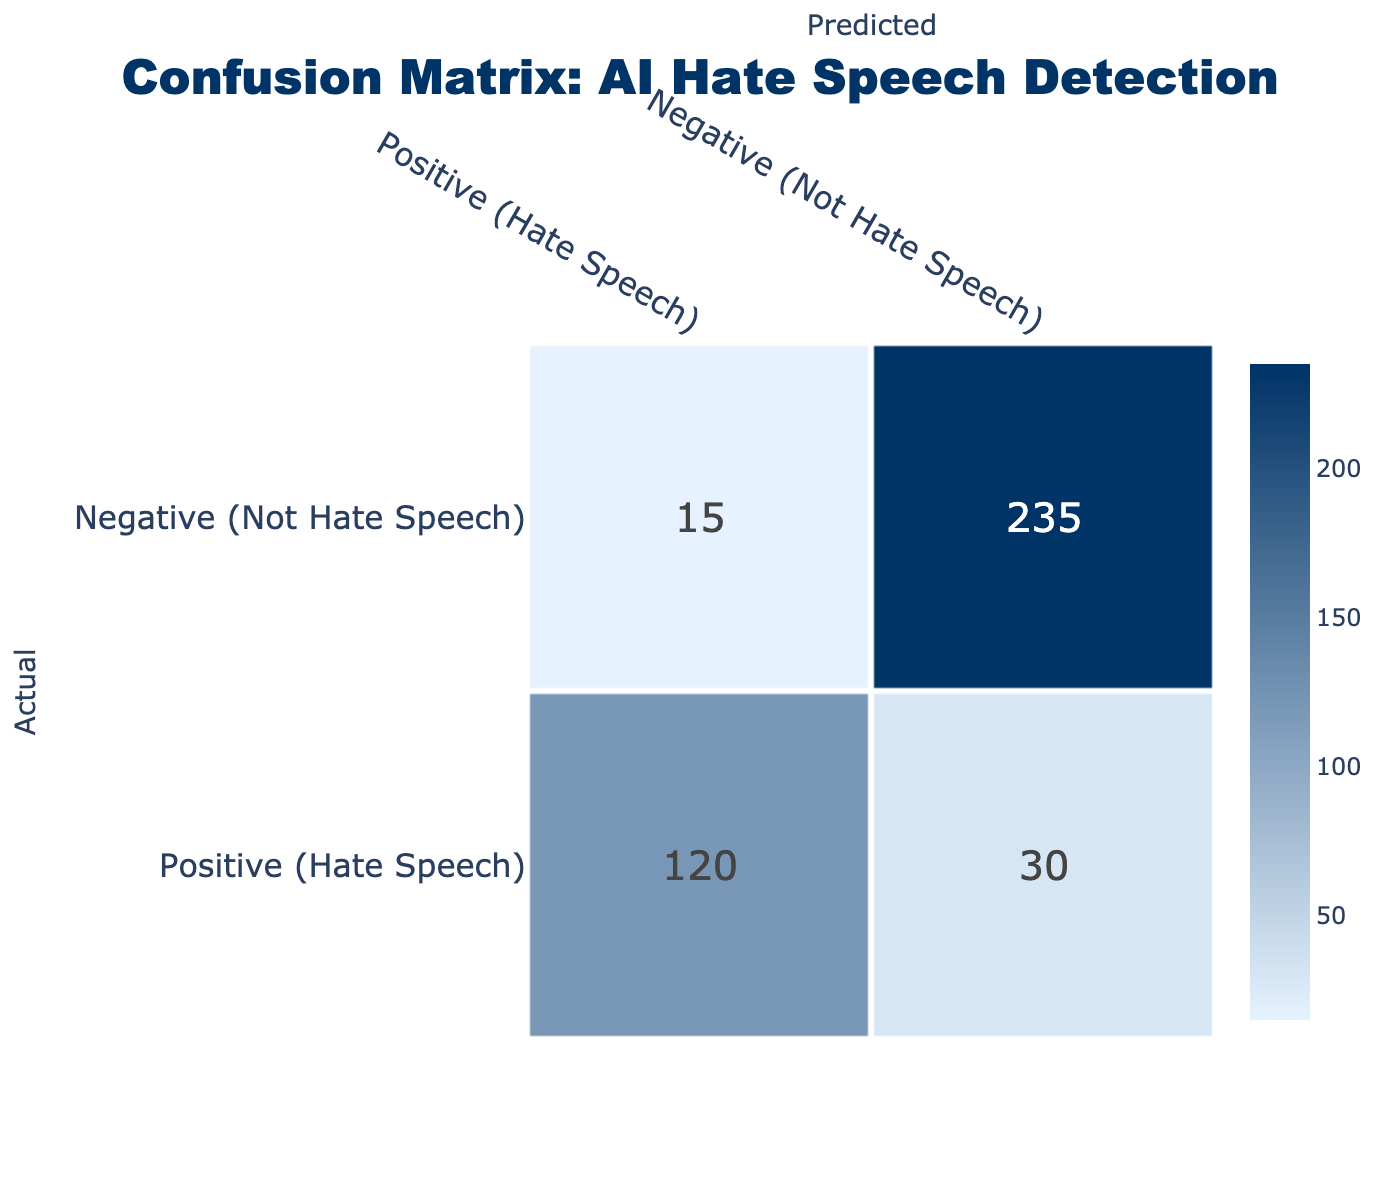What is the total number of instances identified as hate speech? To find the total number of instances identified as hate speech, we look at the Positive (Hate Speech) row in the table. The values in this row indicate the predicted results for actual hate speech. Thus, 120 (true positives) + 30 (false negatives) = 150 instances identified as hate speech.
Answer: 150 How many instances were incorrectly identified as not hate speech? Instances that were incorrectly identified as not hate speech refer to the false negatives, which are located in the Positive (Hate Speech) row under the Negative (Not Hate Speech) column. The value is 30.
Answer: 30 What is the total number of instances predicted as hate speech? To find the total number of instances predicted as hate speech, we need to look at the Positive (Hate Speech) column. The sum is 120 (true positives) + 15 (false positives) = 135 predicted as hate speech.
Answer: 135 What percentage of actual hate speech was correctly detected by the AI system? To find the percentage of actual hate speech that was correctly detected, we divide the number of true positives (120) by the total number of actual hate speech instances (120 + 30). This gives us 120 / 150 = 0.8, or 80%.
Answer: 80% Is it true that the AI incorrectly labeled more instances as hate speech than it correctly detected? To verify this, we compare the false positives (15) in the Negative (Not Hate Speech) row under Positive (Hate Speech) with the true positives (120). Since 15 is less than 120, this statement is false.
Answer: No What is the total number of instances predicted as not hate speech? To calculate the total predicted as not hate speech, we look at the Negative (Not Hate Speech) column. Adding 15 (false positives) and 235 (true negatives) gives us 250 instances predicted as not hate speech.
Answer: 250 How many true negatives were identified by the AI system? The true negatives are the values found in the Negative (Not Hate Speech) row under the Negative (Not Hate Speech) column. This value is 235.
Answer: 235 What is the ratio of incorrectly identified hate speech to correctly identified hate speech? To find this ratio, we look at the false negatives (30) and true positives (120). The ratio of incorrect to correct is 30:120, which simplifies to 1:4.
Answer: 1:4 What number represents the total instances categorized as not hate speech? For total instances categorized as not hate speech, we sum the values in the Negative (Not Hate Speech) row, which is 15 (false positives) + 235 (true negatives) = 250.
Answer: 250 